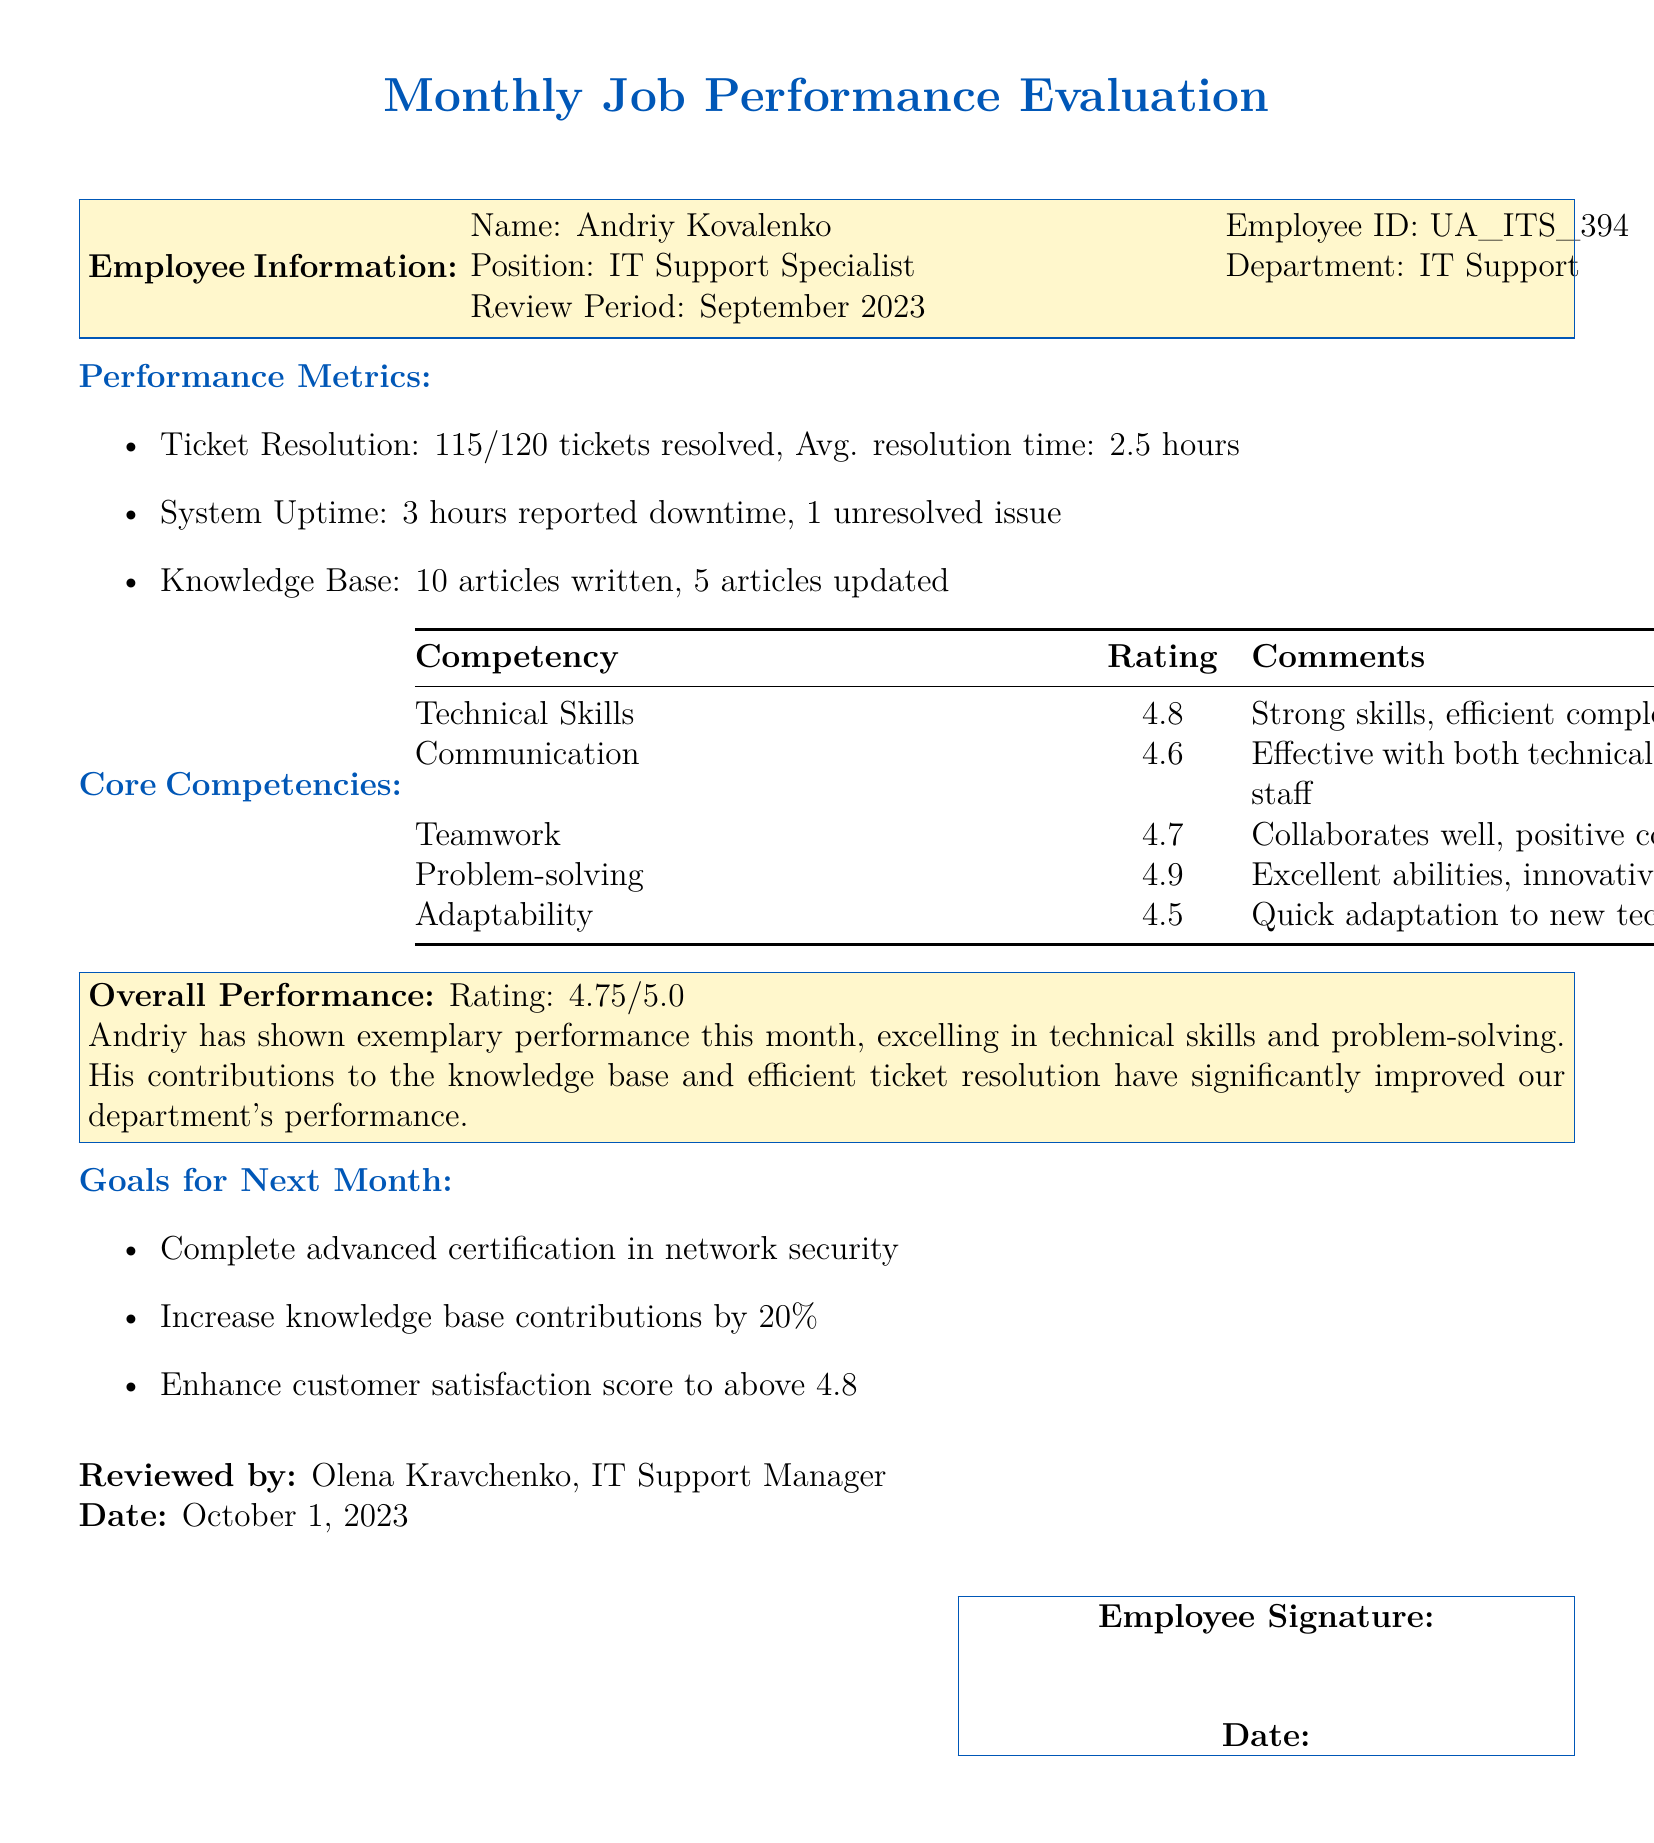What is the employee's name? The employee's name is mentioned in the Employee Information section of the document.
Answer: Andriy Kovalenko What is the employee ID? The employee ID can be found in the Employee Information section.
Answer: UA_ITS_394 What is the review period? The review period is specified in the Employee Information section.
Answer: September 2023 How many tickets were resolved? The number of resolved tickets is in the Performance Metrics section.
Answer: 115 What is the overall performance rating? The overall performance rating is provided in the Overall Performance section.
Answer: 4.75/5.0 Which competency has the highest rating? The competencies and their ratings are listed in the Core Competencies table.
Answer: Problem-solving What was the total downtime reported? The total downtime is mentioned in the Performance Metrics section.
Answer: 3 hours What certification goal is set for next month? The goals for next month are listed at the end of the document.
Answer: Advanced certification in network security Who reviewed the appraisal? The name of the reviewer is stated at the end of the document.
Answer: Olena Kravchenko What is the goal for customer satisfaction? The goal for customer satisfaction can be found in the Goals for Next Month section.
Answer: Above 4.8 